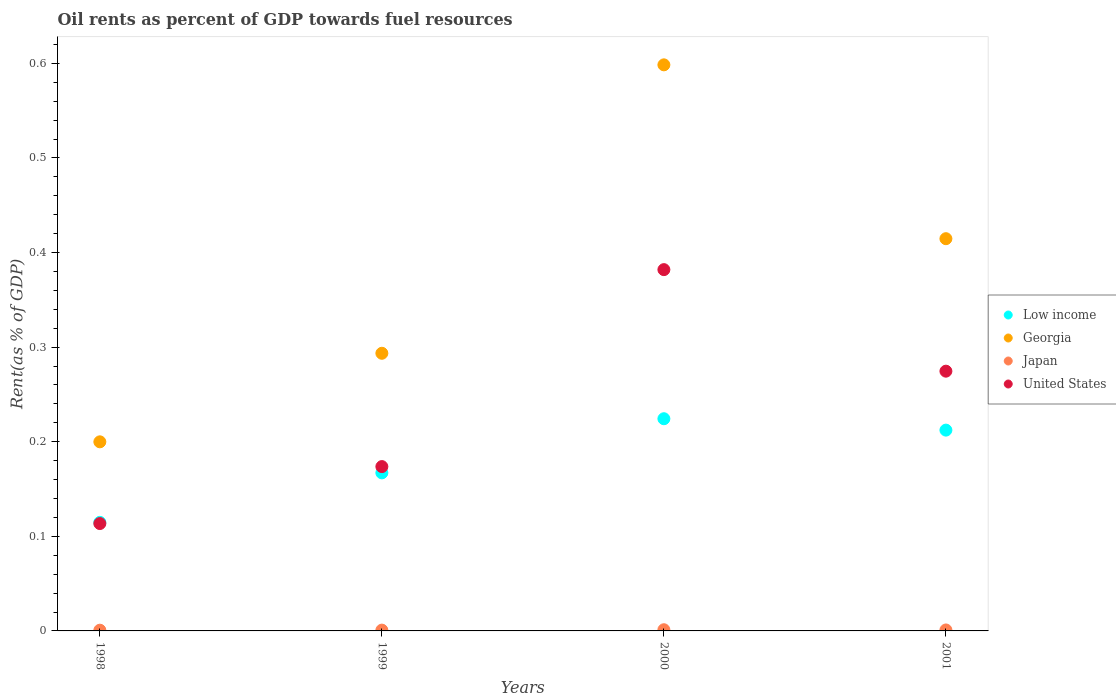Is the number of dotlines equal to the number of legend labels?
Keep it short and to the point. Yes. What is the oil rent in United States in 2001?
Your answer should be compact. 0.27. Across all years, what is the maximum oil rent in United States?
Keep it short and to the point. 0.38. Across all years, what is the minimum oil rent in Japan?
Your response must be concise. 0. In which year was the oil rent in United States maximum?
Make the answer very short. 2000. What is the total oil rent in United States in the graph?
Your response must be concise. 0.94. What is the difference between the oil rent in United States in 1998 and that in 2001?
Give a very brief answer. -0.16. What is the difference between the oil rent in Georgia in 2001 and the oil rent in Japan in 2000?
Provide a succinct answer. 0.41. What is the average oil rent in United States per year?
Keep it short and to the point. 0.24. In the year 2000, what is the difference between the oil rent in Japan and oil rent in United States?
Ensure brevity in your answer.  -0.38. What is the ratio of the oil rent in United States in 2000 to that in 2001?
Keep it short and to the point. 1.39. Is the difference between the oil rent in Japan in 1998 and 2001 greater than the difference between the oil rent in United States in 1998 and 2001?
Provide a succinct answer. Yes. What is the difference between the highest and the second highest oil rent in Georgia?
Your response must be concise. 0.18. What is the difference between the highest and the lowest oil rent in United States?
Your response must be concise. 0.27. In how many years, is the oil rent in Low income greater than the average oil rent in Low income taken over all years?
Your response must be concise. 2. Is the sum of the oil rent in United States in 1998 and 2000 greater than the maximum oil rent in Georgia across all years?
Provide a succinct answer. No. Is it the case that in every year, the sum of the oil rent in Georgia and oil rent in Low income  is greater than the sum of oil rent in Japan and oil rent in United States?
Offer a very short reply. No. How many dotlines are there?
Offer a terse response. 4. How many years are there in the graph?
Provide a short and direct response. 4. What is the difference between two consecutive major ticks on the Y-axis?
Give a very brief answer. 0.1. Are the values on the major ticks of Y-axis written in scientific E-notation?
Ensure brevity in your answer.  No. Does the graph contain any zero values?
Ensure brevity in your answer.  No. What is the title of the graph?
Provide a succinct answer. Oil rents as percent of GDP towards fuel resources. What is the label or title of the Y-axis?
Offer a terse response. Rent(as % of GDP). What is the Rent(as % of GDP) in Low income in 1998?
Keep it short and to the point. 0.11. What is the Rent(as % of GDP) of Georgia in 1998?
Ensure brevity in your answer.  0.2. What is the Rent(as % of GDP) in Japan in 1998?
Ensure brevity in your answer.  0. What is the Rent(as % of GDP) in United States in 1998?
Give a very brief answer. 0.11. What is the Rent(as % of GDP) in Low income in 1999?
Offer a very short reply. 0.17. What is the Rent(as % of GDP) of Georgia in 1999?
Make the answer very short. 0.29. What is the Rent(as % of GDP) of Japan in 1999?
Provide a succinct answer. 0. What is the Rent(as % of GDP) in United States in 1999?
Your answer should be compact. 0.17. What is the Rent(as % of GDP) in Low income in 2000?
Provide a succinct answer. 0.22. What is the Rent(as % of GDP) of Georgia in 2000?
Ensure brevity in your answer.  0.6. What is the Rent(as % of GDP) of Japan in 2000?
Offer a very short reply. 0. What is the Rent(as % of GDP) in United States in 2000?
Your answer should be compact. 0.38. What is the Rent(as % of GDP) in Low income in 2001?
Provide a short and direct response. 0.21. What is the Rent(as % of GDP) of Georgia in 2001?
Your answer should be compact. 0.41. What is the Rent(as % of GDP) of Japan in 2001?
Keep it short and to the point. 0. What is the Rent(as % of GDP) in United States in 2001?
Make the answer very short. 0.27. Across all years, what is the maximum Rent(as % of GDP) of Low income?
Provide a short and direct response. 0.22. Across all years, what is the maximum Rent(as % of GDP) in Georgia?
Keep it short and to the point. 0.6. Across all years, what is the maximum Rent(as % of GDP) in Japan?
Ensure brevity in your answer.  0. Across all years, what is the maximum Rent(as % of GDP) in United States?
Make the answer very short. 0.38. Across all years, what is the minimum Rent(as % of GDP) of Low income?
Your response must be concise. 0.11. Across all years, what is the minimum Rent(as % of GDP) in Georgia?
Keep it short and to the point. 0.2. Across all years, what is the minimum Rent(as % of GDP) in Japan?
Your answer should be compact. 0. Across all years, what is the minimum Rent(as % of GDP) of United States?
Offer a terse response. 0.11. What is the total Rent(as % of GDP) of Low income in the graph?
Provide a short and direct response. 0.72. What is the total Rent(as % of GDP) in Georgia in the graph?
Offer a very short reply. 1.51. What is the total Rent(as % of GDP) in Japan in the graph?
Your answer should be very brief. 0. What is the total Rent(as % of GDP) of United States in the graph?
Offer a very short reply. 0.94. What is the difference between the Rent(as % of GDP) in Low income in 1998 and that in 1999?
Give a very brief answer. -0.05. What is the difference between the Rent(as % of GDP) in Georgia in 1998 and that in 1999?
Your response must be concise. -0.09. What is the difference between the Rent(as % of GDP) of Japan in 1998 and that in 1999?
Make the answer very short. -0. What is the difference between the Rent(as % of GDP) in United States in 1998 and that in 1999?
Offer a terse response. -0.06. What is the difference between the Rent(as % of GDP) of Low income in 1998 and that in 2000?
Offer a terse response. -0.11. What is the difference between the Rent(as % of GDP) in Georgia in 1998 and that in 2000?
Your response must be concise. -0.4. What is the difference between the Rent(as % of GDP) of Japan in 1998 and that in 2000?
Make the answer very short. -0. What is the difference between the Rent(as % of GDP) of United States in 1998 and that in 2000?
Provide a short and direct response. -0.27. What is the difference between the Rent(as % of GDP) in Low income in 1998 and that in 2001?
Offer a very short reply. -0.1. What is the difference between the Rent(as % of GDP) in Georgia in 1998 and that in 2001?
Keep it short and to the point. -0.21. What is the difference between the Rent(as % of GDP) in Japan in 1998 and that in 2001?
Offer a very short reply. -0. What is the difference between the Rent(as % of GDP) of United States in 1998 and that in 2001?
Provide a succinct answer. -0.16. What is the difference between the Rent(as % of GDP) in Low income in 1999 and that in 2000?
Your answer should be compact. -0.06. What is the difference between the Rent(as % of GDP) of Georgia in 1999 and that in 2000?
Your answer should be very brief. -0.3. What is the difference between the Rent(as % of GDP) in Japan in 1999 and that in 2000?
Ensure brevity in your answer.  -0. What is the difference between the Rent(as % of GDP) of United States in 1999 and that in 2000?
Make the answer very short. -0.21. What is the difference between the Rent(as % of GDP) in Low income in 1999 and that in 2001?
Your answer should be very brief. -0.05. What is the difference between the Rent(as % of GDP) in Georgia in 1999 and that in 2001?
Your answer should be compact. -0.12. What is the difference between the Rent(as % of GDP) of Japan in 1999 and that in 2001?
Your answer should be very brief. -0. What is the difference between the Rent(as % of GDP) in United States in 1999 and that in 2001?
Offer a very short reply. -0.1. What is the difference between the Rent(as % of GDP) of Low income in 2000 and that in 2001?
Offer a very short reply. 0.01. What is the difference between the Rent(as % of GDP) in Georgia in 2000 and that in 2001?
Give a very brief answer. 0.18. What is the difference between the Rent(as % of GDP) in Japan in 2000 and that in 2001?
Your answer should be very brief. 0. What is the difference between the Rent(as % of GDP) of United States in 2000 and that in 2001?
Offer a terse response. 0.11. What is the difference between the Rent(as % of GDP) of Low income in 1998 and the Rent(as % of GDP) of Georgia in 1999?
Provide a short and direct response. -0.18. What is the difference between the Rent(as % of GDP) of Low income in 1998 and the Rent(as % of GDP) of Japan in 1999?
Your response must be concise. 0.11. What is the difference between the Rent(as % of GDP) of Low income in 1998 and the Rent(as % of GDP) of United States in 1999?
Give a very brief answer. -0.06. What is the difference between the Rent(as % of GDP) of Georgia in 1998 and the Rent(as % of GDP) of Japan in 1999?
Ensure brevity in your answer.  0.2. What is the difference between the Rent(as % of GDP) in Georgia in 1998 and the Rent(as % of GDP) in United States in 1999?
Provide a short and direct response. 0.03. What is the difference between the Rent(as % of GDP) in Japan in 1998 and the Rent(as % of GDP) in United States in 1999?
Your answer should be very brief. -0.17. What is the difference between the Rent(as % of GDP) of Low income in 1998 and the Rent(as % of GDP) of Georgia in 2000?
Offer a very short reply. -0.48. What is the difference between the Rent(as % of GDP) of Low income in 1998 and the Rent(as % of GDP) of Japan in 2000?
Your response must be concise. 0.11. What is the difference between the Rent(as % of GDP) in Low income in 1998 and the Rent(as % of GDP) in United States in 2000?
Offer a very short reply. -0.27. What is the difference between the Rent(as % of GDP) of Georgia in 1998 and the Rent(as % of GDP) of Japan in 2000?
Provide a succinct answer. 0.2. What is the difference between the Rent(as % of GDP) of Georgia in 1998 and the Rent(as % of GDP) of United States in 2000?
Keep it short and to the point. -0.18. What is the difference between the Rent(as % of GDP) of Japan in 1998 and the Rent(as % of GDP) of United States in 2000?
Your response must be concise. -0.38. What is the difference between the Rent(as % of GDP) in Low income in 1998 and the Rent(as % of GDP) in Georgia in 2001?
Provide a short and direct response. -0.3. What is the difference between the Rent(as % of GDP) of Low income in 1998 and the Rent(as % of GDP) of Japan in 2001?
Offer a terse response. 0.11. What is the difference between the Rent(as % of GDP) in Low income in 1998 and the Rent(as % of GDP) in United States in 2001?
Ensure brevity in your answer.  -0.16. What is the difference between the Rent(as % of GDP) in Georgia in 1998 and the Rent(as % of GDP) in Japan in 2001?
Provide a succinct answer. 0.2. What is the difference between the Rent(as % of GDP) of Georgia in 1998 and the Rent(as % of GDP) of United States in 2001?
Your answer should be compact. -0.07. What is the difference between the Rent(as % of GDP) of Japan in 1998 and the Rent(as % of GDP) of United States in 2001?
Keep it short and to the point. -0.27. What is the difference between the Rent(as % of GDP) of Low income in 1999 and the Rent(as % of GDP) of Georgia in 2000?
Your answer should be very brief. -0.43. What is the difference between the Rent(as % of GDP) in Low income in 1999 and the Rent(as % of GDP) in Japan in 2000?
Your answer should be very brief. 0.17. What is the difference between the Rent(as % of GDP) of Low income in 1999 and the Rent(as % of GDP) of United States in 2000?
Offer a terse response. -0.21. What is the difference between the Rent(as % of GDP) in Georgia in 1999 and the Rent(as % of GDP) in Japan in 2000?
Provide a short and direct response. 0.29. What is the difference between the Rent(as % of GDP) of Georgia in 1999 and the Rent(as % of GDP) of United States in 2000?
Your response must be concise. -0.09. What is the difference between the Rent(as % of GDP) of Japan in 1999 and the Rent(as % of GDP) of United States in 2000?
Offer a very short reply. -0.38. What is the difference between the Rent(as % of GDP) in Low income in 1999 and the Rent(as % of GDP) in Georgia in 2001?
Give a very brief answer. -0.25. What is the difference between the Rent(as % of GDP) of Low income in 1999 and the Rent(as % of GDP) of Japan in 2001?
Make the answer very short. 0.17. What is the difference between the Rent(as % of GDP) in Low income in 1999 and the Rent(as % of GDP) in United States in 2001?
Your response must be concise. -0.11. What is the difference between the Rent(as % of GDP) of Georgia in 1999 and the Rent(as % of GDP) of Japan in 2001?
Offer a very short reply. 0.29. What is the difference between the Rent(as % of GDP) of Georgia in 1999 and the Rent(as % of GDP) of United States in 2001?
Ensure brevity in your answer.  0.02. What is the difference between the Rent(as % of GDP) in Japan in 1999 and the Rent(as % of GDP) in United States in 2001?
Ensure brevity in your answer.  -0.27. What is the difference between the Rent(as % of GDP) in Low income in 2000 and the Rent(as % of GDP) in Georgia in 2001?
Provide a short and direct response. -0.19. What is the difference between the Rent(as % of GDP) of Low income in 2000 and the Rent(as % of GDP) of Japan in 2001?
Your answer should be very brief. 0.22. What is the difference between the Rent(as % of GDP) of Low income in 2000 and the Rent(as % of GDP) of United States in 2001?
Ensure brevity in your answer.  -0.05. What is the difference between the Rent(as % of GDP) in Georgia in 2000 and the Rent(as % of GDP) in Japan in 2001?
Your answer should be very brief. 0.6. What is the difference between the Rent(as % of GDP) of Georgia in 2000 and the Rent(as % of GDP) of United States in 2001?
Your answer should be very brief. 0.32. What is the difference between the Rent(as % of GDP) in Japan in 2000 and the Rent(as % of GDP) in United States in 2001?
Provide a succinct answer. -0.27. What is the average Rent(as % of GDP) in Low income per year?
Keep it short and to the point. 0.18. What is the average Rent(as % of GDP) in Georgia per year?
Provide a short and direct response. 0.38. What is the average Rent(as % of GDP) in United States per year?
Offer a terse response. 0.24. In the year 1998, what is the difference between the Rent(as % of GDP) of Low income and Rent(as % of GDP) of Georgia?
Give a very brief answer. -0.09. In the year 1998, what is the difference between the Rent(as % of GDP) of Low income and Rent(as % of GDP) of Japan?
Offer a very short reply. 0.11. In the year 1998, what is the difference between the Rent(as % of GDP) of Low income and Rent(as % of GDP) of United States?
Give a very brief answer. 0. In the year 1998, what is the difference between the Rent(as % of GDP) in Georgia and Rent(as % of GDP) in Japan?
Your answer should be compact. 0.2. In the year 1998, what is the difference between the Rent(as % of GDP) of Georgia and Rent(as % of GDP) of United States?
Offer a very short reply. 0.09. In the year 1998, what is the difference between the Rent(as % of GDP) of Japan and Rent(as % of GDP) of United States?
Give a very brief answer. -0.11. In the year 1999, what is the difference between the Rent(as % of GDP) of Low income and Rent(as % of GDP) of Georgia?
Provide a short and direct response. -0.13. In the year 1999, what is the difference between the Rent(as % of GDP) of Low income and Rent(as % of GDP) of Japan?
Offer a terse response. 0.17. In the year 1999, what is the difference between the Rent(as % of GDP) in Low income and Rent(as % of GDP) in United States?
Offer a terse response. -0.01. In the year 1999, what is the difference between the Rent(as % of GDP) of Georgia and Rent(as % of GDP) of Japan?
Provide a succinct answer. 0.29. In the year 1999, what is the difference between the Rent(as % of GDP) in Georgia and Rent(as % of GDP) in United States?
Offer a terse response. 0.12. In the year 1999, what is the difference between the Rent(as % of GDP) in Japan and Rent(as % of GDP) in United States?
Offer a very short reply. -0.17. In the year 2000, what is the difference between the Rent(as % of GDP) in Low income and Rent(as % of GDP) in Georgia?
Give a very brief answer. -0.37. In the year 2000, what is the difference between the Rent(as % of GDP) of Low income and Rent(as % of GDP) of Japan?
Provide a succinct answer. 0.22. In the year 2000, what is the difference between the Rent(as % of GDP) in Low income and Rent(as % of GDP) in United States?
Offer a very short reply. -0.16. In the year 2000, what is the difference between the Rent(as % of GDP) of Georgia and Rent(as % of GDP) of Japan?
Provide a succinct answer. 0.6. In the year 2000, what is the difference between the Rent(as % of GDP) of Georgia and Rent(as % of GDP) of United States?
Offer a very short reply. 0.22. In the year 2000, what is the difference between the Rent(as % of GDP) of Japan and Rent(as % of GDP) of United States?
Your answer should be very brief. -0.38. In the year 2001, what is the difference between the Rent(as % of GDP) in Low income and Rent(as % of GDP) in Georgia?
Make the answer very short. -0.2. In the year 2001, what is the difference between the Rent(as % of GDP) of Low income and Rent(as % of GDP) of Japan?
Provide a short and direct response. 0.21. In the year 2001, what is the difference between the Rent(as % of GDP) of Low income and Rent(as % of GDP) of United States?
Your response must be concise. -0.06. In the year 2001, what is the difference between the Rent(as % of GDP) of Georgia and Rent(as % of GDP) of Japan?
Your answer should be compact. 0.41. In the year 2001, what is the difference between the Rent(as % of GDP) in Georgia and Rent(as % of GDP) in United States?
Provide a short and direct response. 0.14. In the year 2001, what is the difference between the Rent(as % of GDP) in Japan and Rent(as % of GDP) in United States?
Give a very brief answer. -0.27. What is the ratio of the Rent(as % of GDP) of Low income in 1998 to that in 1999?
Your response must be concise. 0.69. What is the ratio of the Rent(as % of GDP) of Georgia in 1998 to that in 1999?
Offer a very short reply. 0.68. What is the ratio of the Rent(as % of GDP) in Japan in 1998 to that in 1999?
Your response must be concise. 0.91. What is the ratio of the Rent(as % of GDP) in United States in 1998 to that in 1999?
Ensure brevity in your answer.  0.65. What is the ratio of the Rent(as % of GDP) of Low income in 1998 to that in 2000?
Provide a succinct answer. 0.51. What is the ratio of the Rent(as % of GDP) in Georgia in 1998 to that in 2000?
Offer a very short reply. 0.33. What is the ratio of the Rent(as % of GDP) in Japan in 1998 to that in 2000?
Your response must be concise. 0.62. What is the ratio of the Rent(as % of GDP) in United States in 1998 to that in 2000?
Keep it short and to the point. 0.3. What is the ratio of the Rent(as % of GDP) of Low income in 1998 to that in 2001?
Your answer should be compact. 0.54. What is the ratio of the Rent(as % of GDP) in Georgia in 1998 to that in 2001?
Provide a succinct answer. 0.48. What is the ratio of the Rent(as % of GDP) of Japan in 1998 to that in 2001?
Offer a terse response. 0.76. What is the ratio of the Rent(as % of GDP) in United States in 1998 to that in 2001?
Your response must be concise. 0.41. What is the ratio of the Rent(as % of GDP) of Low income in 1999 to that in 2000?
Make the answer very short. 0.74. What is the ratio of the Rent(as % of GDP) in Georgia in 1999 to that in 2000?
Make the answer very short. 0.49. What is the ratio of the Rent(as % of GDP) in Japan in 1999 to that in 2000?
Provide a succinct answer. 0.68. What is the ratio of the Rent(as % of GDP) of United States in 1999 to that in 2000?
Offer a very short reply. 0.45. What is the ratio of the Rent(as % of GDP) in Low income in 1999 to that in 2001?
Your response must be concise. 0.79. What is the ratio of the Rent(as % of GDP) in Georgia in 1999 to that in 2001?
Give a very brief answer. 0.71. What is the ratio of the Rent(as % of GDP) in Japan in 1999 to that in 2001?
Offer a terse response. 0.83. What is the ratio of the Rent(as % of GDP) of United States in 1999 to that in 2001?
Provide a short and direct response. 0.63. What is the ratio of the Rent(as % of GDP) of Low income in 2000 to that in 2001?
Your answer should be very brief. 1.06. What is the ratio of the Rent(as % of GDP) in Georgia in 2000 to that in 2001?
Your response must be concise. 1.44. What is the ratio of the Rent(as % of GDP) in Japan in 2000 to that in 2001?
Your answer should be compact. 1.23. What is the ratio of the Rent(as % of GDP) in United States in 2000 to that in 2001?
Keep it short and to the point. 1.39. What is the difference between the highest and the second highest Rent(as % of GDP) in Low income?
Offer a terse response. 0.01. What is the difference between the highest and the second highest Rent(as % of GDP) in Georgia?
Your answer should be compact. 0.18. What is the difference between the highest and the second highest Rent(as % of GDP) of United States?
Your answer should be very brief. 0.11. What is the difference between the highest and the lowest Rent(as % of GDP) in Low income?
Your response must be concise. 0.11. What is the difference between the highest and the lowest Rent(as % of GDP) of Georgia?
Make the answer very short. 0.4. What is the difference between the highest and the lowest Rent(as % of GDP) of United States?
Provide a succinct answer. 0.27. 